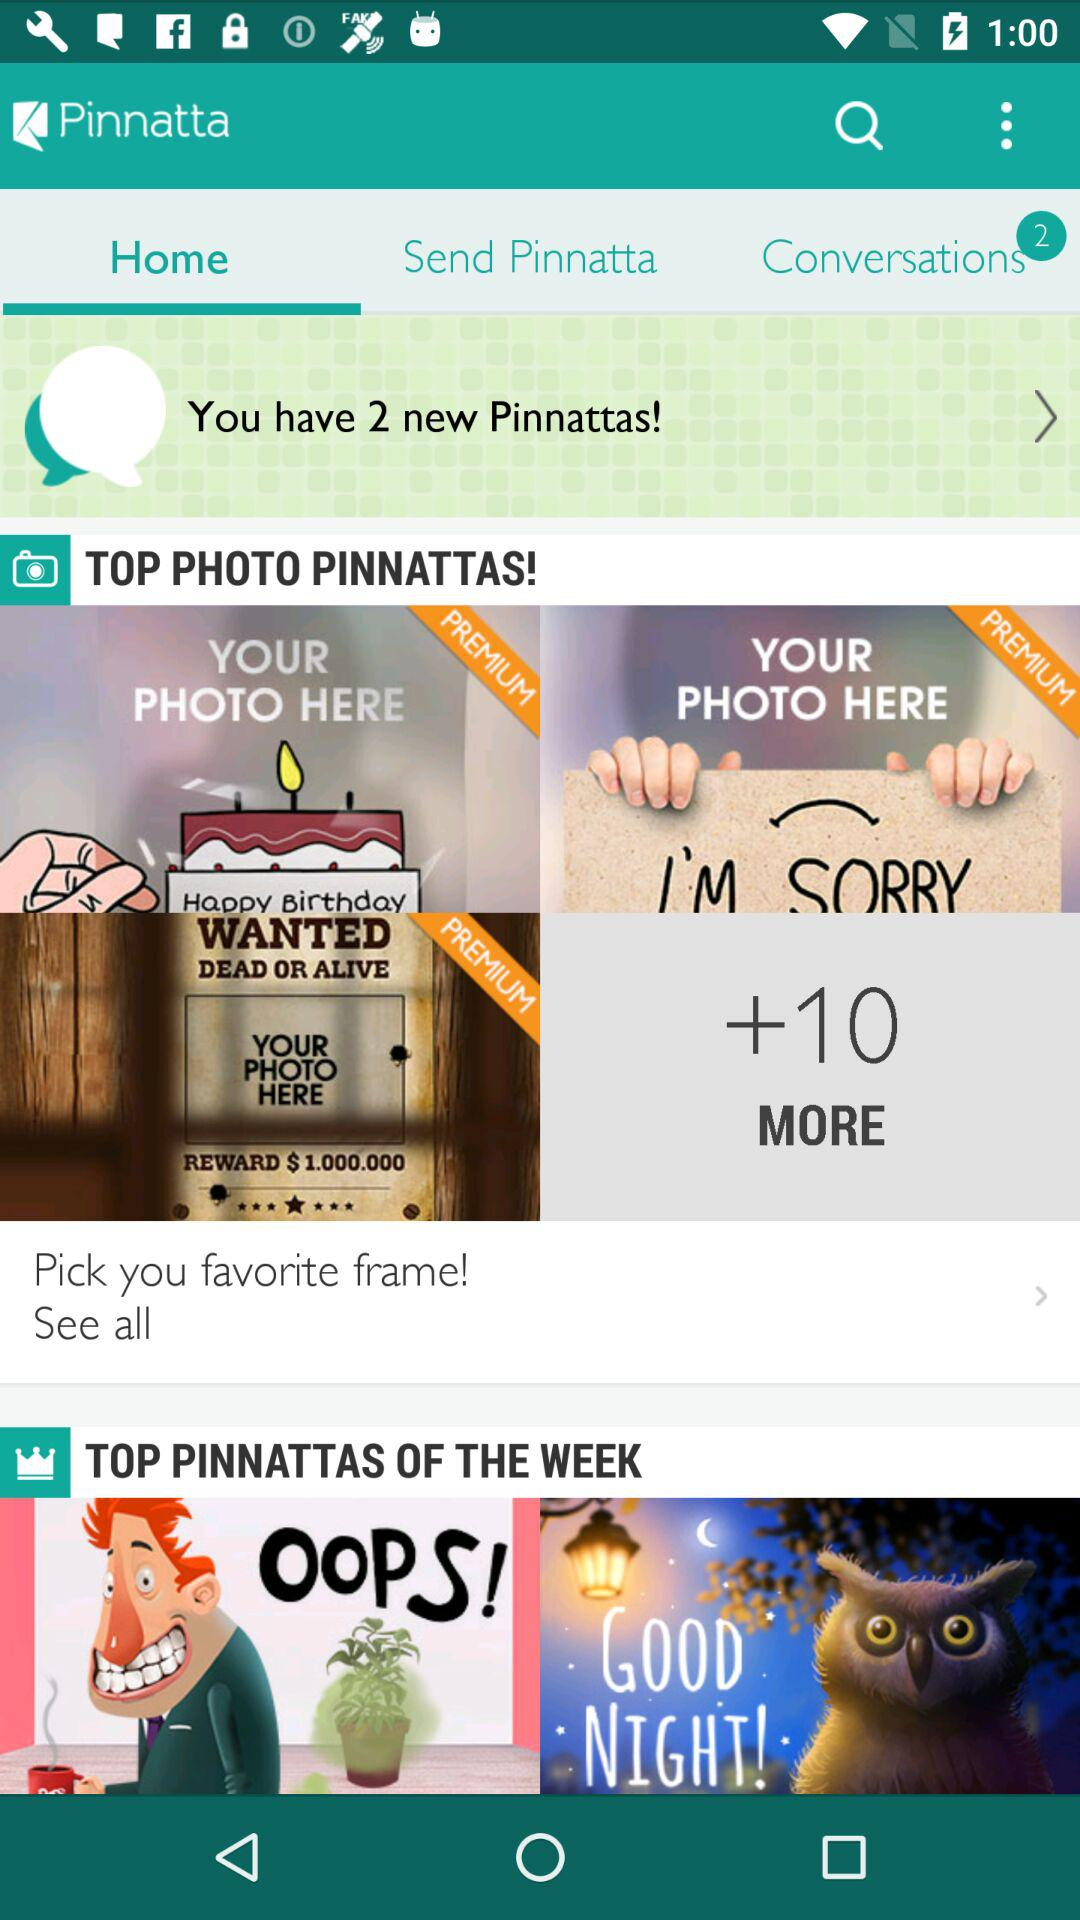Which tab is selected? The selected tab is "Home". 